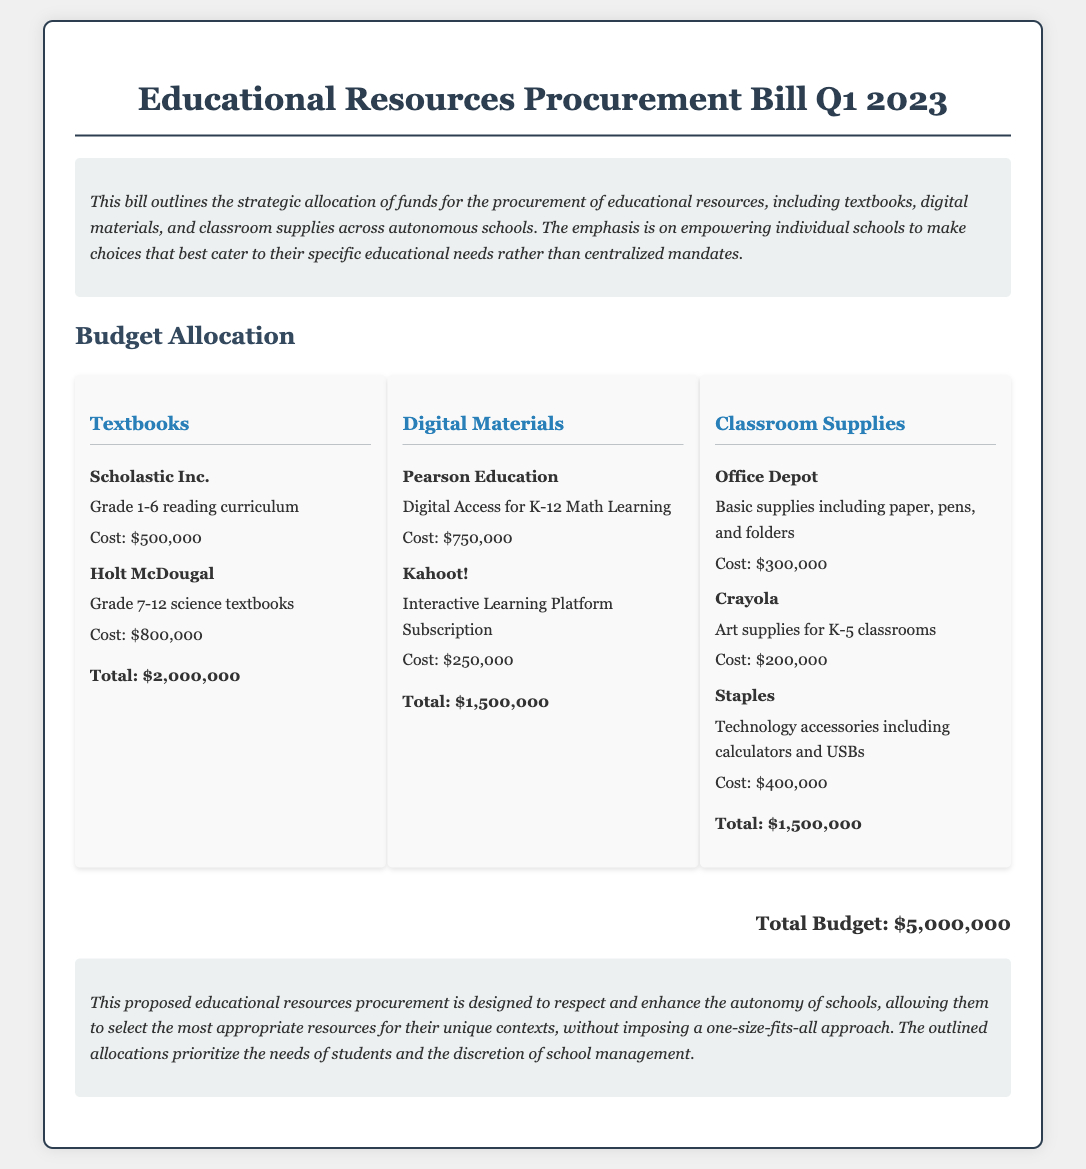What is the total budget allocated? The total budget is stated clearly at the end of the bill summary, which sums all allocations.
Answer: $5,000,000 Who is the vendor for digital access in K-12 Math Learning? The vendor providing digital access for K-12 Math Learning is mentioned in the digital materials section.
Answer: Pearson Education How much is allocated for textbooks? The total cost of textbooks is explicitly listed in the textbook category of the budget allocation.
Answer: $2,000,000 What type of supplies does Office Depot provide? The specific type of supplies provided by Office Depot is detailed in the classroom supplies category.
Answer: Basic supplies including paper, pens, and folders What is the cost of the interactive learning platform subscription? The cost of the subscription for the interactive learning platform is mentioned in the digital materials section.
Answer: $250,000 Which vendor supplies art supplies for K-5 classrooms? The vendor providing art supplies for K-5 classrooms is identified in the classroom supplies section.
Answer: Crayola What is the total allocation for digital materials? The total amount allocated for digital materials is summarized in the digital materials category.
Answer: $1,500,000 What does the bill emphasize regarding school autonomy? The emphasis placed on school autonomy is discussed in the introduction of the bill.
Answer: Empowering individual schools How many vendors are listed for classroom supplies? The number of vendors for classroom supplies can be counted from the classroom supplies section of the document.
Answer: Three 